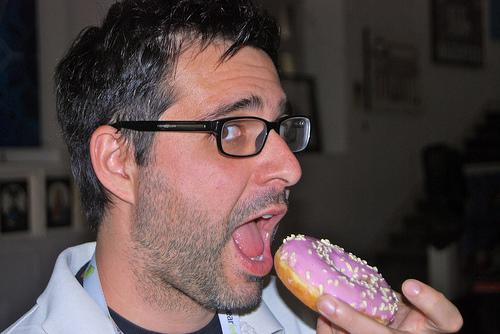Analyze the primary interaction between the man and the doughnuts in the image. The man appears to be in the process of eating the doughnut, showcasing a strong interaction between his sense of taste and the doughnuts' appearance and flavor. What are the key elements in this picture, and what emotions do they convey? The key elements are a man with a unique appearance eating a doughnut and showing excitement. The overall emotion conveyed is enjoyment. What do you think the man in the image feels and why? The man probably feels excitement and enjoyment because he is eating a delectable doughnut with a mouth wide open and tongue hanging out. Identify the primary focus of the image and explain the scene. The image mainly focuses on a man with distinctive facial features who appears to be in the process of eating a glazed doughnut with pink frosting and sprinkles. Provide a brief description of the scene from the perspective of an observer who just walked in. I see a man with a distinct appearance, eating a delicious-looking doughnut with pink glaze and sprinkles, as he wears a pair of black glasses with excitement on his face. Comment on the quality of the image and how well it represents the objects in it. The image quality seems to be satisfactory, clearly depicting the man with his unique facial features and doughnuts, making it easy to understand the scene. Mention the number of men and doughnuts in the image and describe any interesting features. There is one man in the image who has a pointed nose, scratchy beard, and wears black glasses. There are two doughnuts: one with pink glaze and another with sprinkles. From the image provided, can you infer the type of doughnut being consumed? A doughnut with frosting and sprinkles. Categorize the event illustrated in the image. man about to eat a donut Identify the key activity occurring in the image. man eating a doughnut What color is the umbrella behind the man? No, it's not mentioned in the image. In the image, is there a man with black hair looking at the camera wearing dark rimmed glasses? Yes Can you read the name on the collar of a shirt in the image? No, it's not possible to read the name. What is the color of the donut's glaze? pink Based on the image, do you think the man is enjoying the donut? Yes, it seems he is enjoying the donut. Locate the balloon floating near the doughnut. This instruction is misleading because there is no mention of a balloon in the image's objects. The given information only contains objects related to a man and doughnuts. Is the following statement true based on the image: A man is eating a doughnut with frosting? True Was the man caught in the act of licking his lips or with his tongue hanging out? tongue hanging out Which object is larger: man's head or doughnut? man's head Which VQA task involves determining emotions portrayed in a face? facial expression detection Identify the dog lying in the corner of the image. This instruction is misleading because there is no mention of a dog in the image's objects. The given information only contains objects related to a man and doughnuts. Select the appropriate emotion exhibited by the man in the image: [Option A: Amused, Option B: Surprised, Option C: Sad, Option D: Angry] Option A: Amused Given the image, describe the appearance of the man's nose. pointed nose What item is pink and being eaten in the image? glazed doughnut Which is the most suitable way to express the man's actions in the image? [Option A: Smiling, Option B: Gazing, Option C: Eating, Option D: Singing] Option C: Eating Examine the image for a specific detail: Does the man have a beard? If so, describe its appearance. Yes, the man has a scruffy beard. 